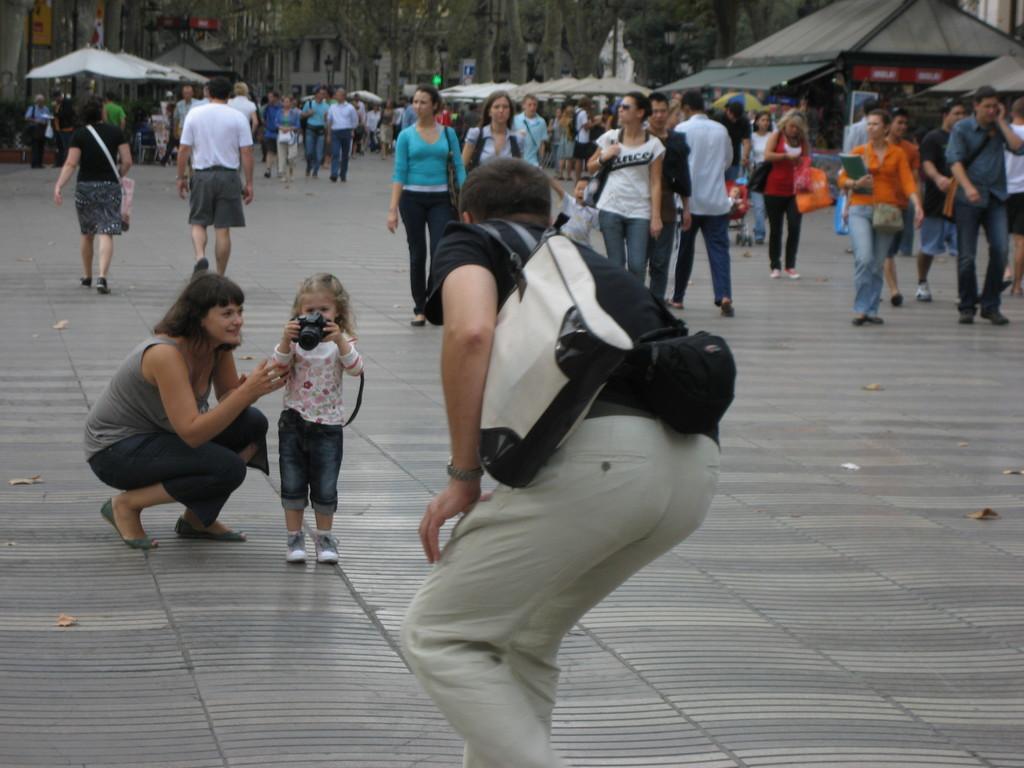Please provide a concise description of this image. In this image we can see one man is standing. He is wearing black color t-shirt with pant and holding white color bag. Left side of the image one girl is standing, she is wearing white color dress with jeans and holding camera in her hand. Beside her one lady is sitting, she is wearing grey color top. Background of the image so many men and women are walking on the road. Top of the image buildings and trees are present. 